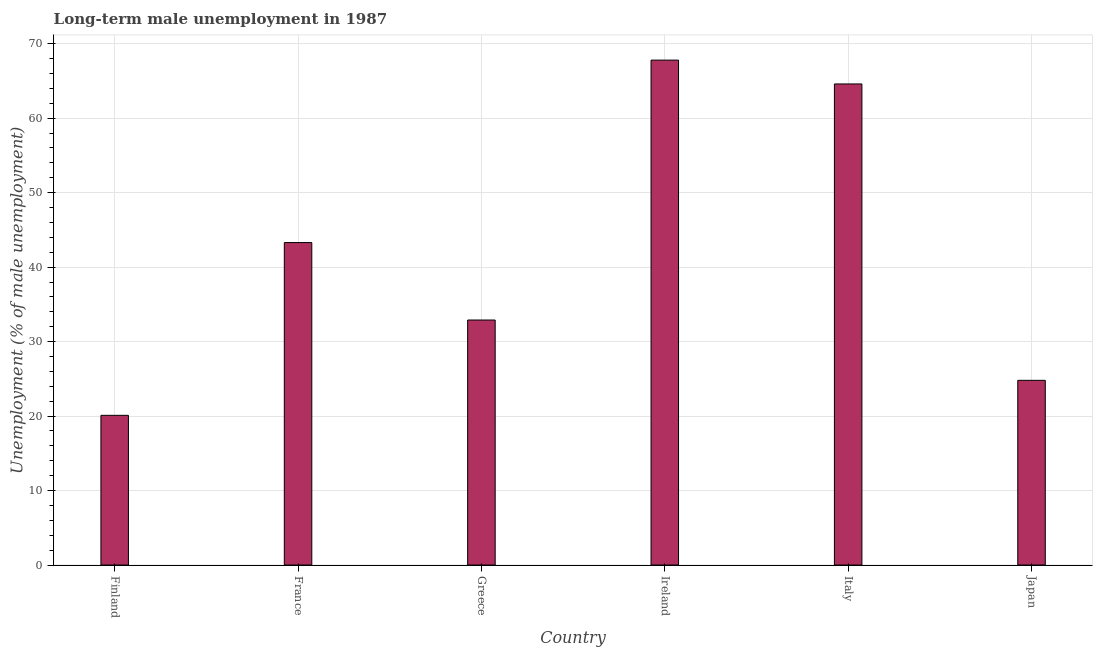Does the graph contain any zero values?
Ensure brevity in your answer.  No. Does the graph contain grids?
Offer a very short reply. Yes. What is the title of the graph?
Your response must be concise. Long-term male unemployment in 1987. What is the label or title of the X-axis?
Your response must be concise. Country. What is the label or title of the Y-axis?
Your answer should be compact. Unemployment (% of male unemployment). What is the long-term male unemployment in Ireland?
Offer a very short reply. 67.8. Across all countries, what is the maximum long-term male unemployment?
Your answer should be compact. 67.8. Across all countries, what is the minimum long-term male unemployment?
Offer a terse response. 20.1. In which country was the long-term male unemployment maximum?
Offer a terse response. Ireland. What is the sum of the long-term male unemployment?
Give a very brief answer. 253.5. What is the difference between the long-term male unemployment in France and Ireland?
Your answer should be very brief. -24.5. What is the average long-term male unemployment per country?
Give a very brief answer. 42.25. What is the median long-term male unemployment?
Your response must be concise. 38.1. In how many countries, is the long-term male unemployment greater than 50 %?
Offer a terse response. 2. What is the ratio of the long-term male unemployment in Ireland to that in Italy?
Offer a very short reply. 1.05. Is the difference between the long-term male unemployment in France and Greece greater than the difference between any two countries?
Offer a very short reply. No. What is the difference between the highest and the second highest long-term male unemployment?
Provide a short and direct response. 3.2. Is the sum of the long-term male unemployment in Finland and Ireland greater than the maximum long-term male unemployment across all countries?
Offer a terse response. Yes. What is the difference between the highest and the lowest long-term male unemployment?
Keep it short and to the point. 47.7. In how many countries, is the long-term male unemployment greater than the average long-term male unemployment taken over all countries?
Provide a short and direct response. 3. How many bars are there?
Offer a terse response. 6. What is the difference between two consecutive major ticks on the Y-axis?
Provide a short and direct response. 10. Are the values on the major ticks of Y-axis written in scientific E-notation?
Keep it short and to the point. No. What is the Unemployment (% of male unemployment) of Finland?
Offer a very short reply. 20.1. What is the Unemployment (% of male unemployment) in France?
Your answer should be very brief. 43.3. What is the Unemployment (% of male unemployment) of Greece?
Your answer should be very brief. 32.9. What is the Unemployment (% of male unemployment) in Ireland?
Provide a short and direct response. 67.8. What is the Unemployment (% of male unemployment) in Italy?
Ensure brevity in your answer.  64.6. What is the Unemployment (% of male unemployment) of Japan?
Offer a very short reply. 24.8. What is the difference between the Unemployment (% of male unemployment) in Finland and France?
Offer a terse response. -23.2. What is the difference between the Unemployment (% of male unemployment) in Finland and Ireland?
Provide a succinct answer. -47.7. What is the difference between the Unemployment (% of male unemployment) in Finland and Italy?
Give a very brief answer. -44.5. What is the difference between the Unemployment (% of male unemployment) in Finland and Japan?
Your answer should be compact. -4.7. What is the difference between the Unemployment (% of male unemployment) in France and Greece?
Your answer should be compact. 10.4. What is the difference between the Unemployment (% of male unemployment) in France and Ireland?
Keep it short and to the point. -24.5. What is the difference between the Unemployment (% of male unemployment) in France and Italy?
Ensure brevity in your answer.  -21.3. What is the difference between the Unemployment (% of male unemployment) in Greece and Ireland?
Offer a very short reply. -34.9. What is the difference between the Unemployment (% of male unemployment) in Greece and Italy?
Offer a very short reply. -31.7. What is the difference between the Unemployment (% of male unemployment) in Greece and Japan?
Make the answer very short. 8.1. What is the difference between the Unemployment (% of male unemployment) in Ireland and Italy?
Your response must be concise. 3.2. What is the difference between the Unemployment (% of male unemployment) in Italy and Japan?
Ensure brevity in your answer.  39.8. What is the ratio of the Unemployment (% of male unemployment) in Finland to that in France?
Offer a very short reply. 0.46. What is the ratio of the Unemployment (% of male unemployment) in Finland to that in Greece?
Offer a very short reply. 0.61. What is the ratio of the Unemployment (% of male unemployment) in Finland to that in Ireland?
Provide a short and direct response. 0.3. What is the ratio of the Unemployment (% of male unemployment) in Finland to that in Italy?
Provide a succinct answer. 0.31. What is the ratio of the Unemployment (% of male unemployment) in Finland to that in Japan?
Provide a short and direct response. 0.81. What is the ratio of the Unemployment (% of male unemployment) in France to that in Greece?
Keep it short and to the point. 1.32. What is the ratio of the Unemployment (% of male unemployment) in France to that in Ireland?
Keep it short and to the point. 0.64. What is the ratio of the Unemployment (% of male unemployment) in France to that in Italy?
Offer a terse response. 0.67. What is the ratio of the Unemployment (% of male unemployment) in France to that in Japan?
Provide a short and direct response. 1.75. What is the ratio of the Unemployment (% of male unemployment) in Greece to that in Ireland?
Give a very brief answer. 0.48. What is the ratio of the Unemployment (% of male unemployment) in Greece to that in Italy?
Provide a short and direct response. 0.51. What is the ratio of the Unemployment (% of male unemployment) in Greece to that in Japan?
Your answer should be compact. 1.33. What is the ratio of the Unemployment (% of male unemployment) in Ireland to that in Italy?
Provide a succinct answer. 1.05. What is the ratio of the Unemployment (% of male unemployment) in Ireland to that in Japan?
Offer a very short reply. 2.73. What is the ratio of the Unemployment (% of male unemployment) in Italy to that in Japan?
Give a very brief answer. 2.6. 